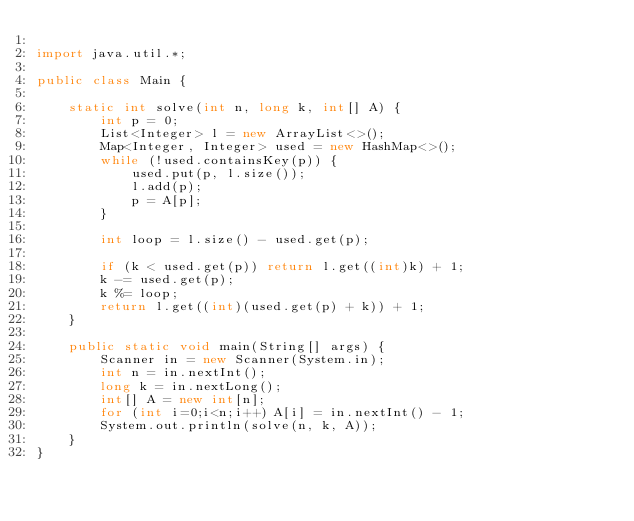<code> <loc_0><loc_0><loc_500><loc_500><_Java_>
import java.util.*;

public class Main {

    static int solve(int n, long k, int[] A) {
        int p = 0;
        List<Integer> l = new ArrayList<>();
        Map<Integer, Integer> used = new HashMap<>();
        while (!used.containsKey(p)) {
            used.put(p, l.size());
            l.add(p);
            p = A[p];
        }

        int loop = l.size() - used.get(p);

        if (k < used.get(p)) return l.get((int)k) + 1;
        k -= used.get(p);
        k %= loop;
        return l.get((int)(used.get(p) + k)) + 1;
    }

    public static void main(String[] args) {
        Scanner in = new Scanner(System.in);
        int n = in.nextInt();
        long k = in.nextLong();
        int[] A = new int[n];
        for (int i=0;i<n;i++) A[i] = in.nextInt() - 1;
        System.out.println(solve(n, k, A));
    }
}
</code> 